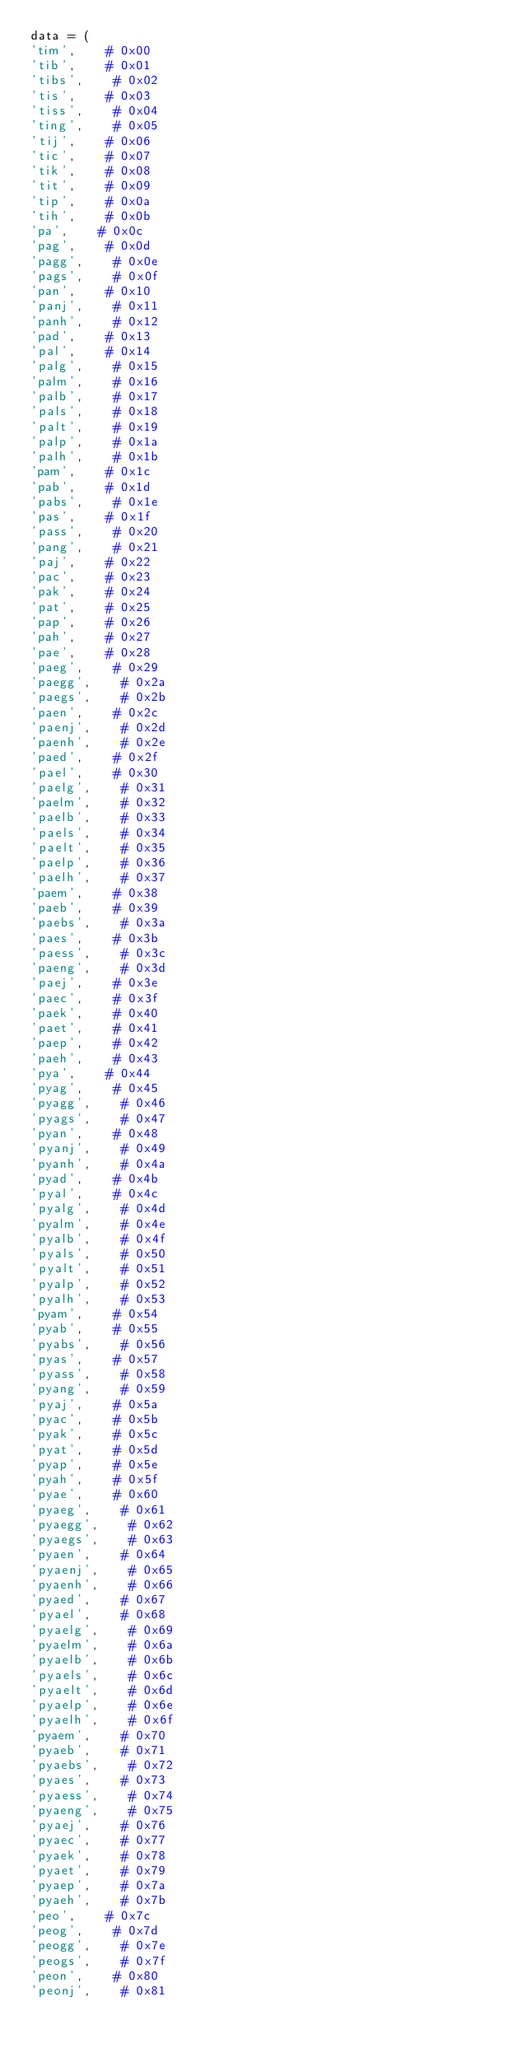Convert code to text. <code><loc_0><loc_0><loc_500><loc_500><_Python_>data = (
'tim',    # 0x00
'tib',    # 0x01
'tibs',    # 0x02
'tis',    # 0x03
'tiss',    # 0x04
'ting',    # 0x05
'tij',    # 0x06
'tic',    # 0x07
'tik',    # 0x08
'tit',    # 0x09
'tip',    # 0x0a
'tih',    # 0x0b
'pa',    # 0x0c
'pag',    # 0x0d
'pagg',    # 0x0e
'pags',    # 0x0f
'pan',    # 0x10
'panj',    # 0x11
'panh',    # 0x12
'pad',    # 0x13
'pal',    # 0x14
'palg',    # 0x15
'palm',    # 0x16
'palb',    # 0x17
'pals',    # 0x18
'palt',    # 0x19
'palp',    # 0x1a
'palh',    # 0x1b
'pam',    # 0x1c
'pab',    # 0x1d
'pabs',    # 0x1e
'pas',    # 0x1f
'pass',    # 0x20
'pang',    # 0x21
'paj',    # 0x22
'pac',    # 0x23
'pak',    # 0x24
'pat',    # 0x25
'pap',    # 0x26
'pah',    # 0x27
'pae',    # 0x28
'paeg',    # 0x29
'paegg',    # 0x2a
'paegs',    # 0x2b
'paen',    # 0x2c
'paenj',    # 0x2d
'paenh',    # 0x2e
'paed',    # 0x2f
'pael',    # 0x30
'paelg',    # 0x31
'paelm',    # 0x32
'paelb',    # 0x33
'paels',    # 0x34
'paelt',    # 0x35
'paelp',    # 0x36
'paelh',    # 0x37
'paem',    # 0x38
'paeb',    # 0x39
'paebs',    # 0x3a
'paes',    # 0x3b
'paess',    # 0x3c
'paeng',    # 0x3d
'paej',    # 0x3e
'paec',    # 0x3f
'paek',    # 0x40
'paet',    # 0x41
'paep',    # 0x42
'paeh',    # 0x43
'pya',    # 0x44
'pyag',    # 0x45
'pyagg',    # 0x46
'pyags',    # 0x47
'pyan',    # 0x48
'pyanj',    # 0x49
'pyanh',    # 0x4a
'pyad',    # 0x4b
'pyal',    # 0x4c
'pyalg',    # 0x4d
'pyalm',    # 0x4e
'pyalb',    # 0x4f
'pyals',    # 0x50
'pyalt',    # 0x51
'pyalp',    # 0x52
'pyalh',    # 0x53
'pyam',    # 0x54
'pyab',    # 0x55
'pyabs',    # 0x56
'pyas',    # 0x57
'pyass',    # 0x58
'pyang',    # 0x59
'pyaj',    # 0x5a
'pyac',    # 0x5b
'pyak',    # 0x5c
'pyat',    # 0x5d
'pyap',    # 0x5e
'pyah',    # 0x5f
'pyae',    # 0x60
'pyaeg',    # 0x61
'pyaegg',    # 0x62
'pyaegs',    # 0x63
'pyaen',    # 0x64
'pyaenj',    # 0x65
'pyaenh',    # 0x66
'pyaed',    # 0x67
'pyael',    # 0x68
'pyaelg',    # 0x69
'pyaelm',    # 0x6a
'pyaelb',    # 0x6b
'pyaels',    # 0x6c
'pyaelt',    # 0x6d
'pyaelp',    # 0x6e
'pyaelh',    # 0x6f
'pyaem',    # 0x70
'pyaeb',    # 0x71
'pyaebs',    # 0x72
'pyaes',    # 0x73
'pyaess',    # 0x74
'pyaeng',    # 0x75
'pyaej',    # 0x76
'pyaec',    # 0x77
'pyaek',    # 0x78
'pyaet',    # 0x79
'pyaep',    # 0x7a
'pyaeh',    # 0x7b
'peo',    # 0x7c
'peog',    # 0x7d
'peogg',    # 0x7e
'peogs',    # 0x7f
'peon',    # 0x80
'peonj',    # 0x81</code> 